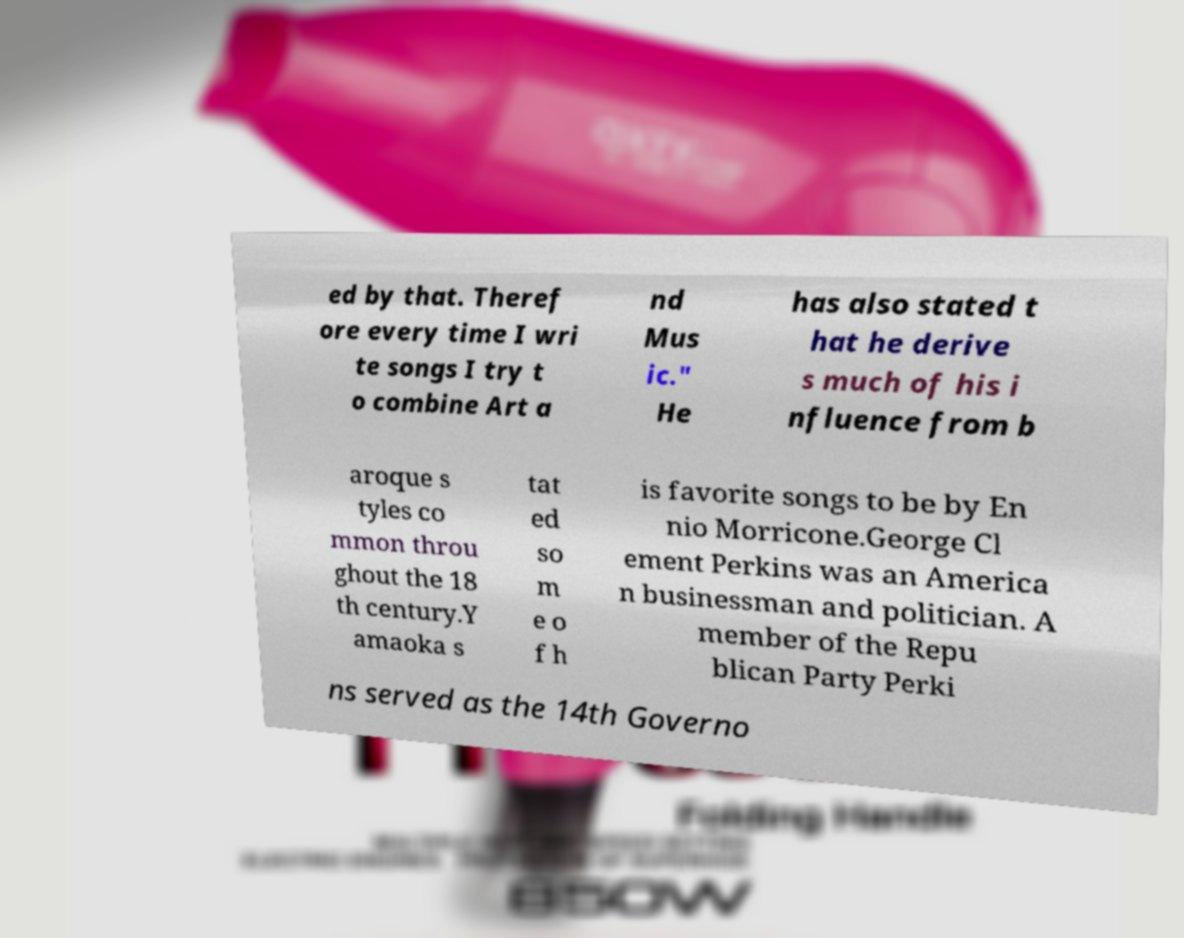For documentation purposes, I need the text within this image transcribed. Could you provide that? ed by that. Theref ore every time I wri te songs I try t o combine Art a nd Mus ic." He has also stated t hat he derive s much of his i nfluence from b aroque s tyles co mmon throu ghout the 18 th century.Y amaoka s tat ed so m e o f h is favorite songs to be by En nio Morricone.George Cl ement Perkins was an America n businessman and politician. A member of the Repu blican Party Perki ns served as the 14th Governo 